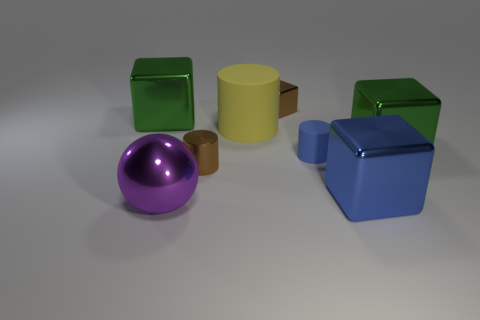Subtract all small brown metal cubes. How many cubes are left? 3 Add 1 green cubes. How many objects exist? 9 Subtract all green cubes. How many cubes are left? 2 Subtract all purple cylinders. How many green cubes are left? 2 Subtract 2 blocks. How many blocks are left? 2 Subtract all brown cylinders. Subtract all cyan spheres. How many cylinders are left? 2 Subtract 0 yellow cubes. How many objects are left? 8 Subtract all cylinders. How many objects are left? 5 Subtract all red matte objects. Subtract all big green objects. How many objects are left? 6 Add 5 small blocks. How many small blocks are left? 6 